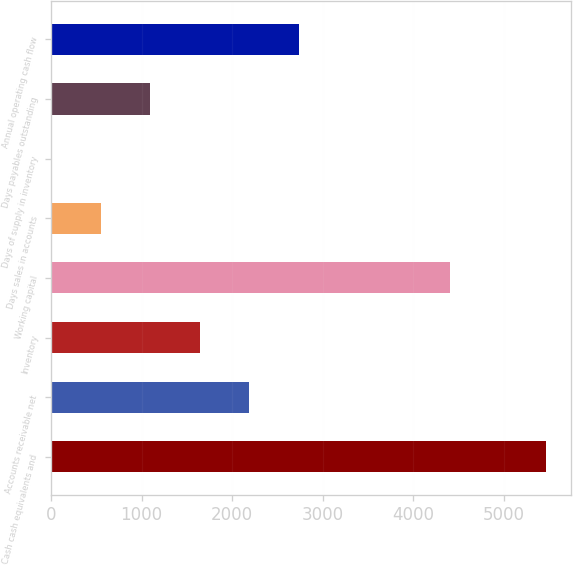Convert chart. <chart><loc_0><loc_0><loc_500><loc_500><bar_chart><fcel>Cash cash equivalents and<fcel>Accounts receivable net<fcel>Inventory<fcel>Working capital<fcel>Days sales in accounts<fcel>Days of supply in inventory<fcel>Days payables outstanding<fcel>Annual operating cash flow<nl><fcel>5464<fcel>2188.6<fcel>1642.7<fcel>4403<fcel>550.9<fcel>5<fcel>1096.8<fcel>2734.5<nl></chart> 